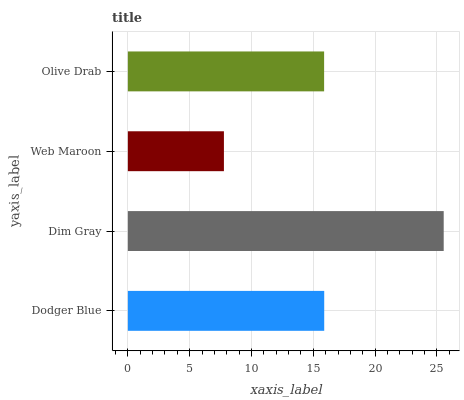Is Web Maroon the minimum?
Answer yes or no. Yes. Is Dim Gray the maximum?
Answer yes or no. Yes. Is Dim Gray the minimum?
Answer yes or no. No. Is Web Maroon the maximum?
Answer yes or no. No. Is Dim Gray greater than Web Maroon?
Answer yes or no. Yes. Is Web Maroon less than Dim Gray?
Answer yes or no. Yes. Is Web Maroon greater than Dim Gray?
Answer yes or no. No. Is Dim Gray less than Web Maroon?
Answer yes or no. No. Is Dodger Blue the high median?
Answer yes or no. Yes. Is Olive Drab the low median?
Answer yes or no. Yes. Is Dim Gray the high median?
Answer yes or no. No. Is Dodger Blue the low median?
Answer yes or no. No. 